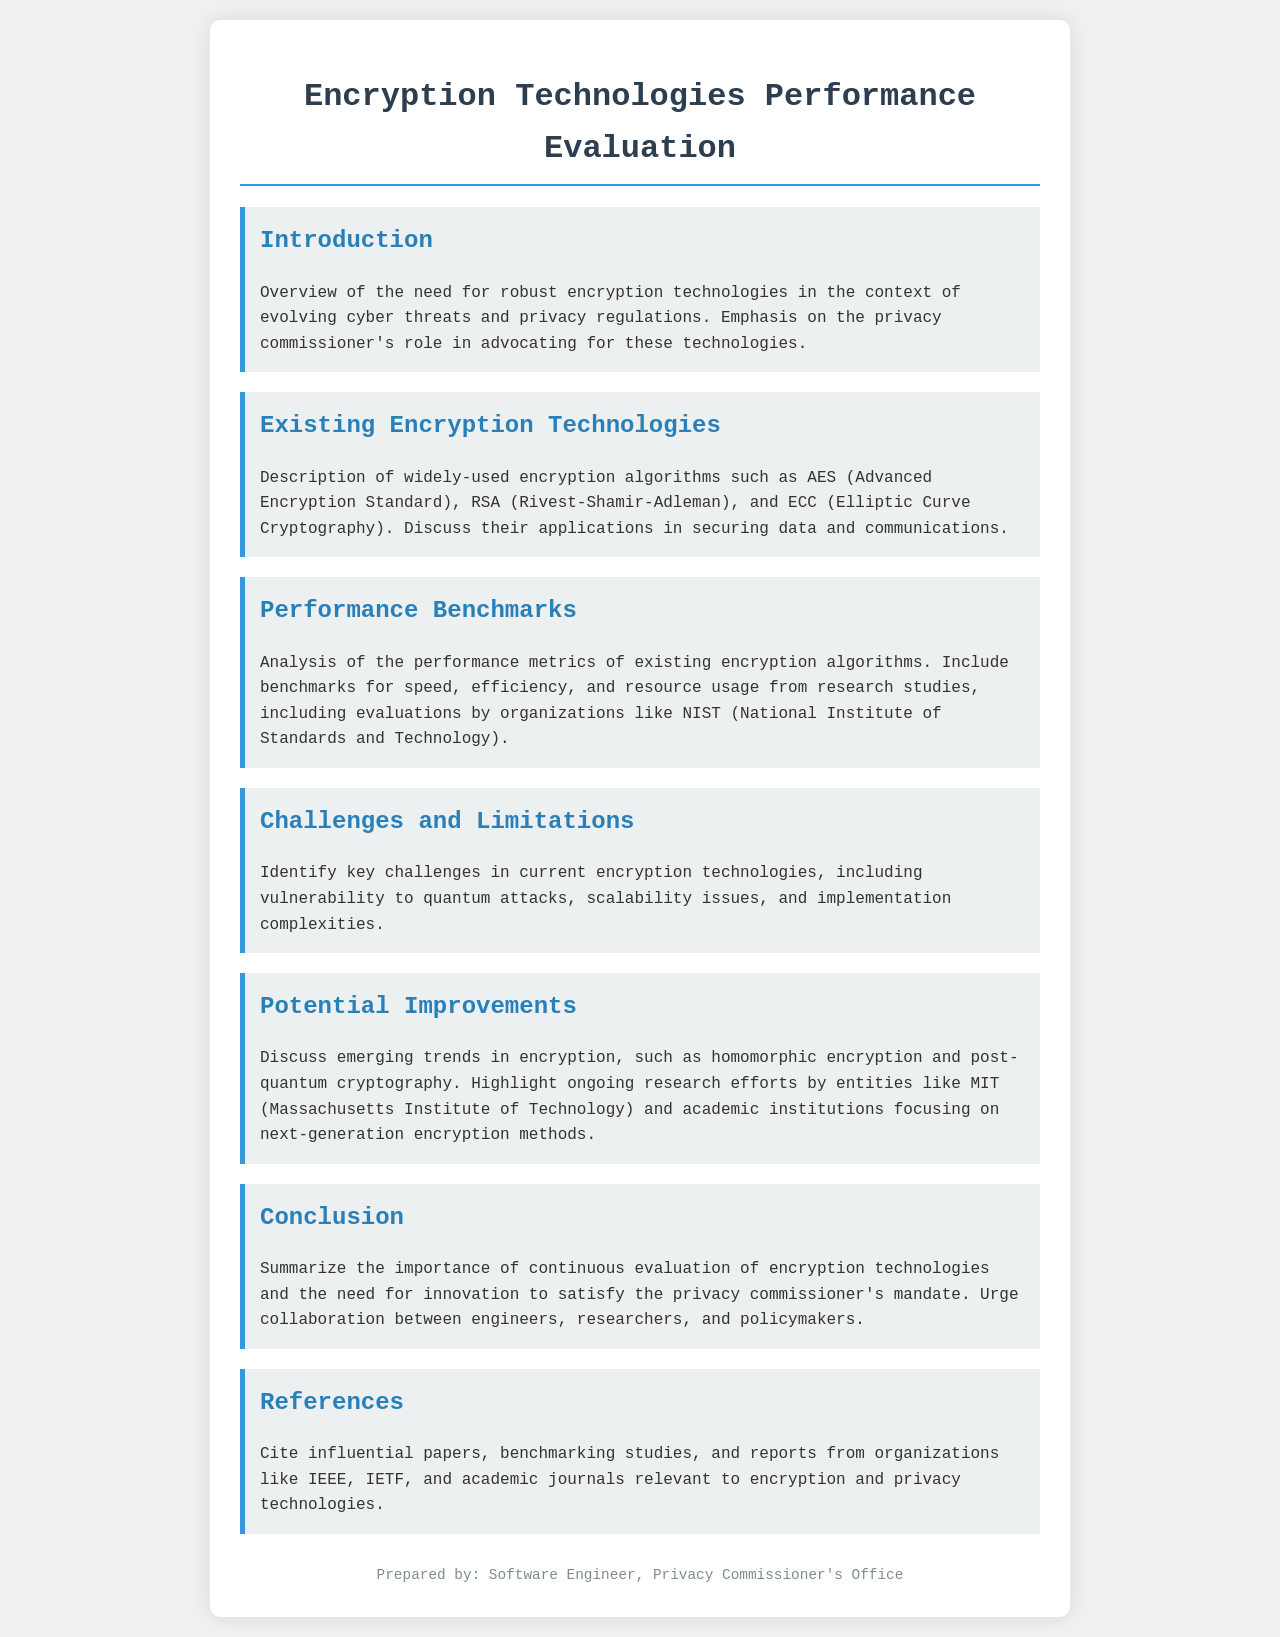What is the title of the document? The title of the document is prominently displayed at the top, indicating the main focus of the content.
Answer: Encryption Technologies Performance Evaluation What is the role of the privacy commissioner? The privacy commissioner is mentioned as an advocate for robust encryption technologies in response to cyber threats and privacy regulations.
Answer: Advocate Which encryption algorithm is widely discussed first? The section describes existing encryption technologies, starting with the most widely used algorithm in this context.
Answer: AES What performance metrics are analyzed? The document mentions several performance metrics related to encryption algorithms, highlighting specific aspects such as speed and resource usage.
Answer: Speed, efficiency, and resource usage What emerging trend in encryption is highlighted? The document discusses new trends in the encryption landscape that represent advancements in the field.
Answer: Homomorphic encryption What academic institution is mentioned for ongoing research efforts? The document references a specific institution known for its influential research in next-generation encryption.
Answer: MIT What are the key challenges identified in encryption technologies? The section details significant issues currently faced by encryption technologies, focusing on vulnerabilities and scalability.
Answer: Vulnerability to quantum attacks What is the final message of the conclusion? The conclusion emphasizes the necessity for collective action among various stakeholders to advance encryption technology.
Answer: Collaboration 